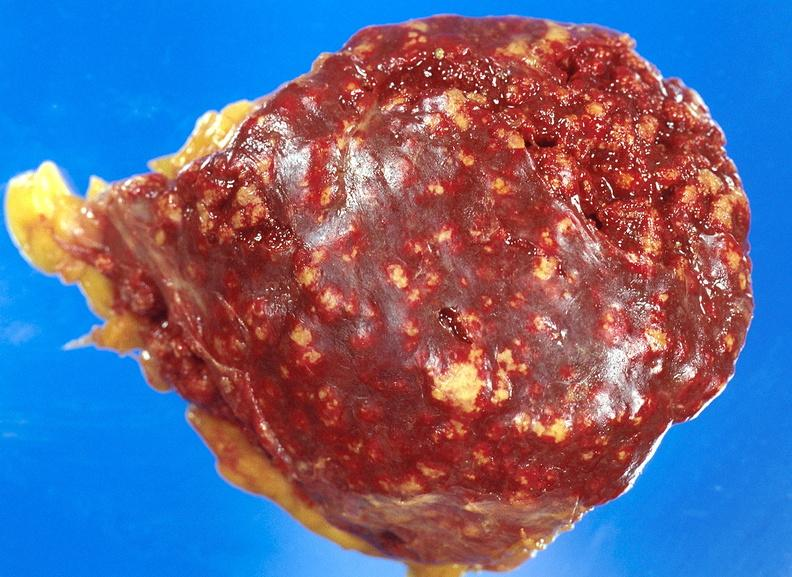what does this image show?
Answer the question using a single word or phrase. Spleen 